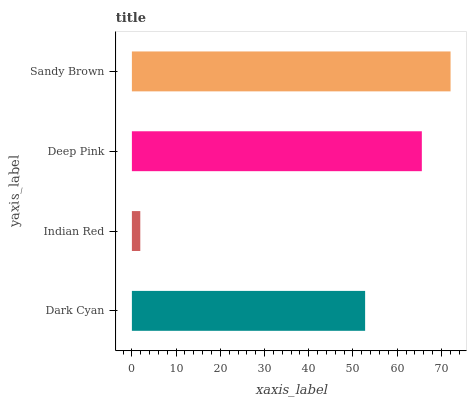Is Indian Red the minimum?
Answer yes or no. Yes. Is Sandy Brown the maximum?
Answer yes or no. Yes. Is Deep Pink the minimum?
Answer yes or no. No. Is Deep Pink the maximum?
Answer yes or no. No. Is Deep Pink greater than Indian Red?
Answer yes or no. Yes. Is Indian Red less than Deep Pink?
Answer yes or no. Yes. Is Indian Red greater than Deep Pink?
Answer yes or no. No. Is Deep Pink less than Indian Red?
Answer yes or no. No. Is Deep Pink the high median?
Answer yes or no. Yes. Is Dark Cyan the low median?
Answer yes or no. Yes. Is Indian Red the high median?
Answer yes or no. No. Is Deep Pink the low median?
Answer yes or no. No. 